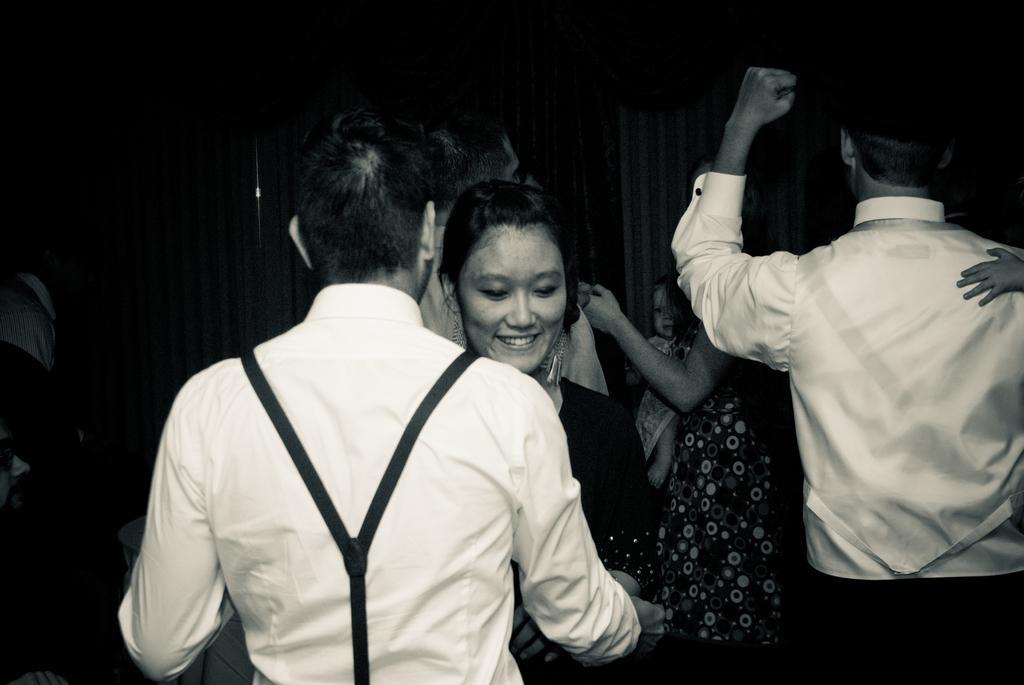Please provide a concise description of this image. In this image, we can see a group of people are standing. Here we can see a woman is smiling. Background we can see a human is carrying a baby. here we can see curtains. 